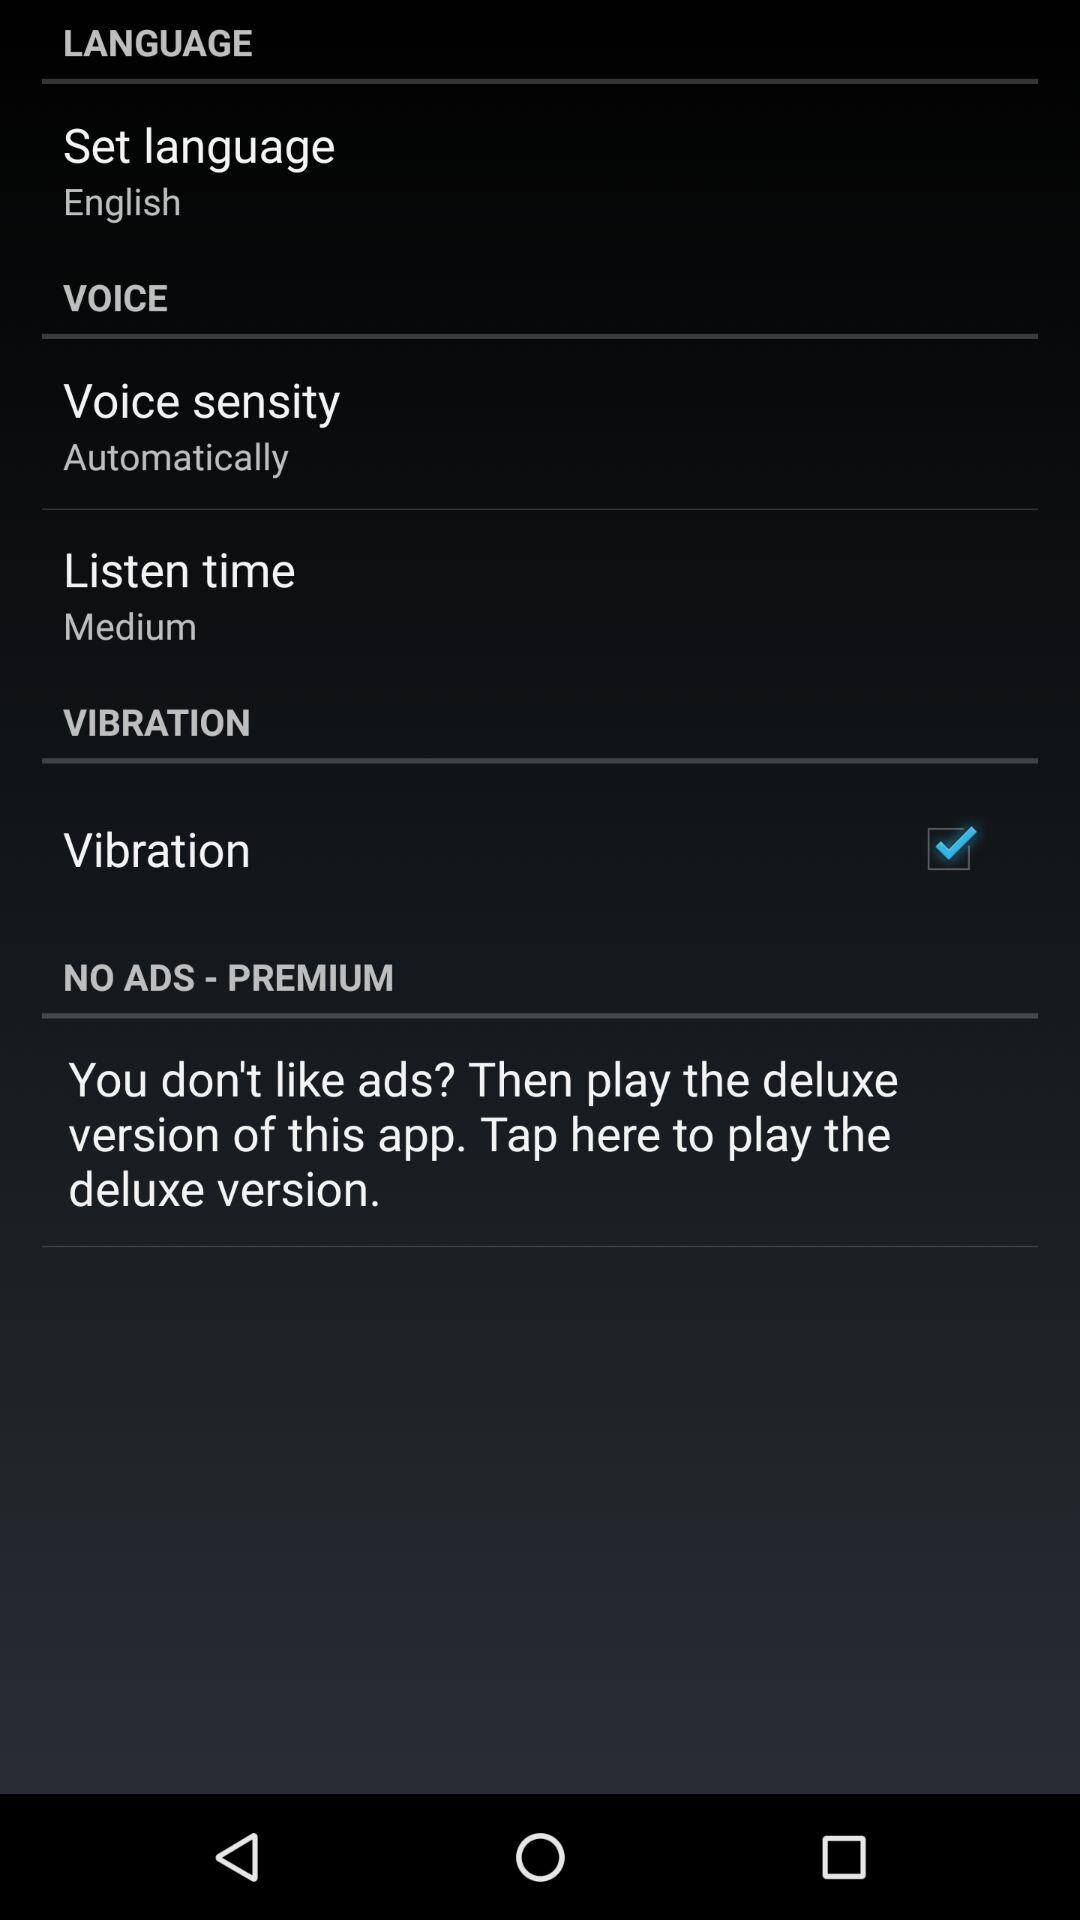What is the set language? The set language is English. 